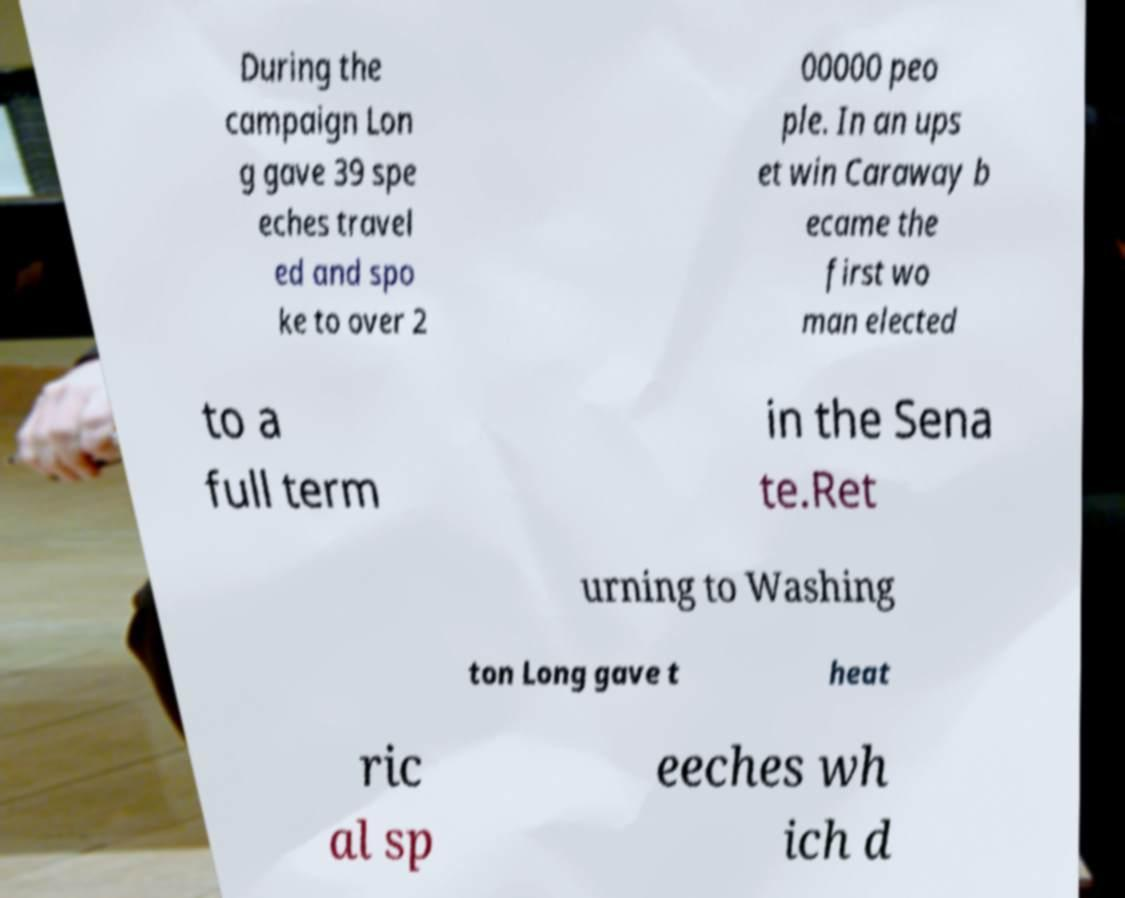For documentation purposes, I need the text within this image transcribed. Could you provide that? During the campaign Lon g gave 39 spe eches travel ed and spo ke to over 2 00000 peo ple. In an ups et win Caraway b ecame the first wo man elected to a full term in the Sena te.Ret urning to Washing ton Long gave t heat ric al sp eeches wh ich d 